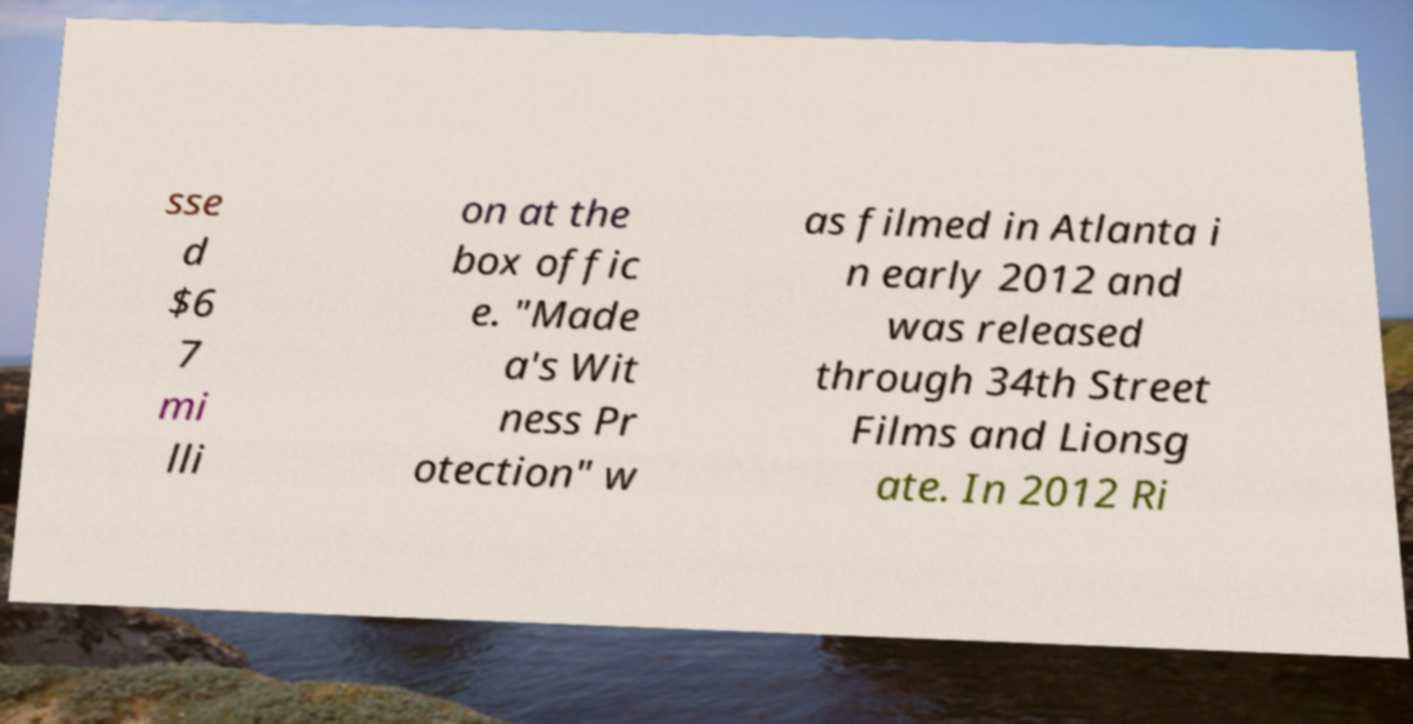What messages or text are displayed in this image? I need them in a readable, typed format. sse d $6 7 mi lli on at the box offic e. "Made a's Wit ness Pr otection" w as filmed in Atlanta i n early 2012 and was released through 34th Street Films and Lionsg ate. In 2012 Ri 